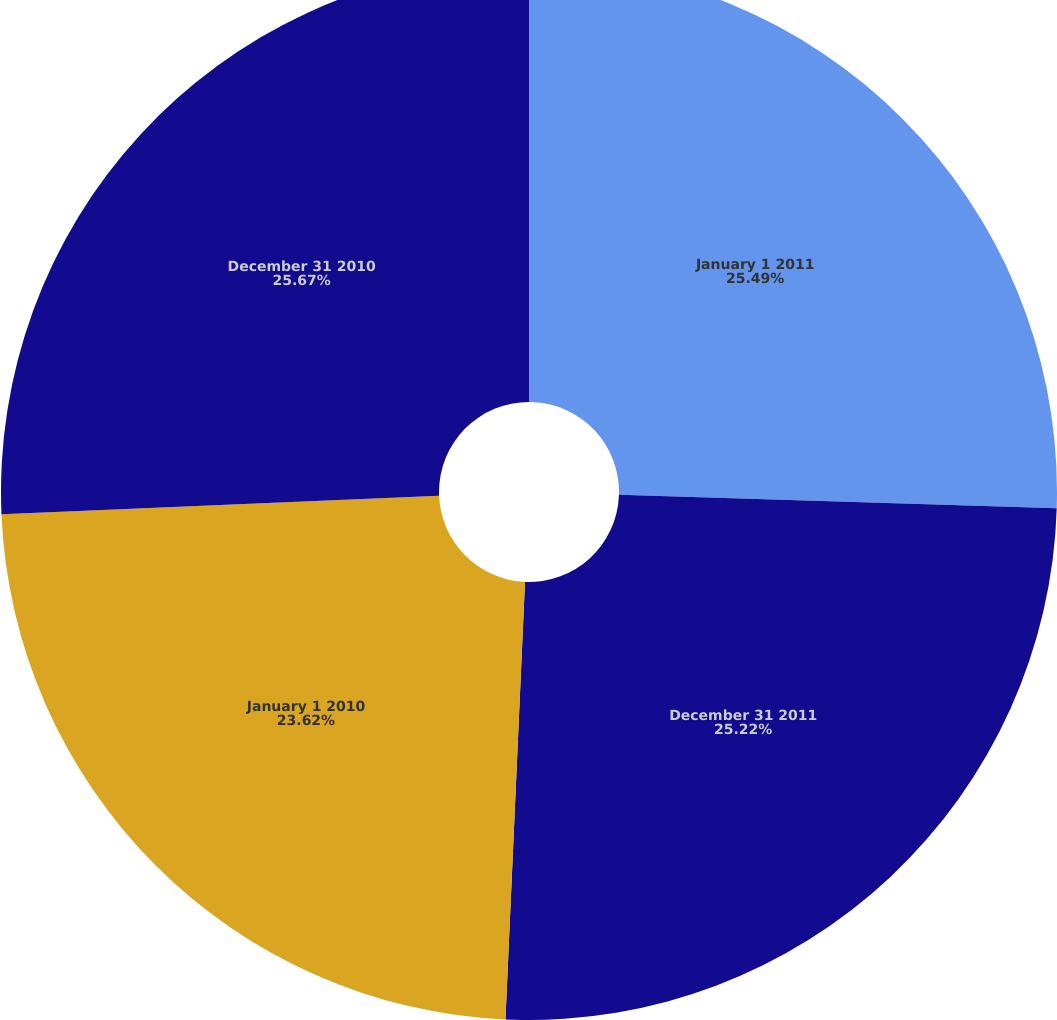Convert chart. <chart><loc_0><loc_0><loc_500><loc_500><pie_chart><fcel>January 1 2011<fcel>December 31 2011<fcel>January 1 2010<fcel>December 31 2010<nl><fcel>25.49%<fcel>25.22%<fcel>23.62%<fcel>25.67%<nl></chart> 